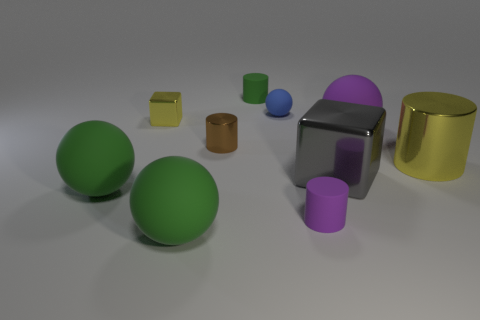Can you describe the different materials that appear to be used for the objects in this image? Certainly! In this image, you can see various objects that seem to be made from different materials. The large gray block and the cylinder on the right appear to have a metallic sheen, suggesting they are made of metal. The spheres and cylinders look like they could be made of a matte plastic or rubber due to their less reflective surfaces. 